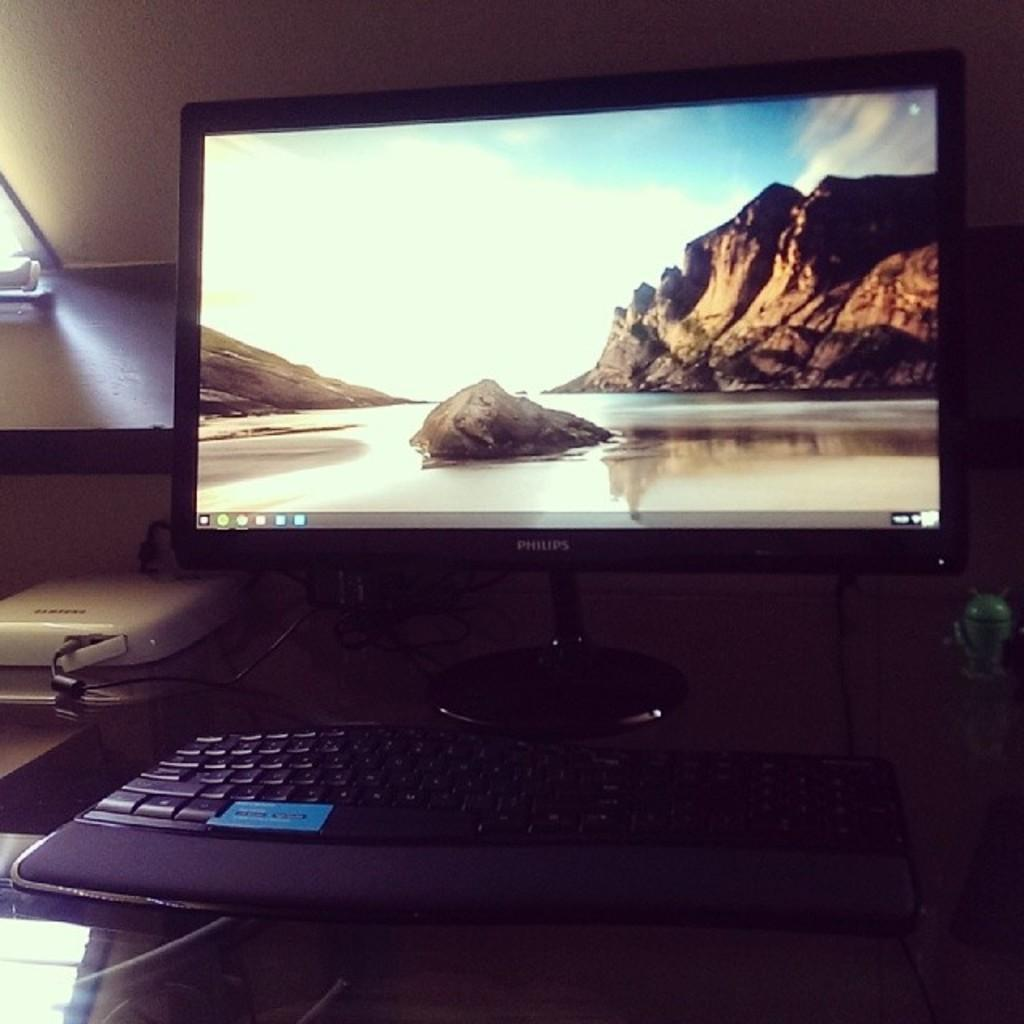What is the main subject of the image? The main subject of the image is a system. What is located on the table in the image? There is located on the table in the image? What can be seen in the background of the image? There is a wall visible in the background of the image. What type of beef is being cooked on the edge of the system in the image? There is no beef or cooking activity present in the image; it features a system and a keyboard on a table. 